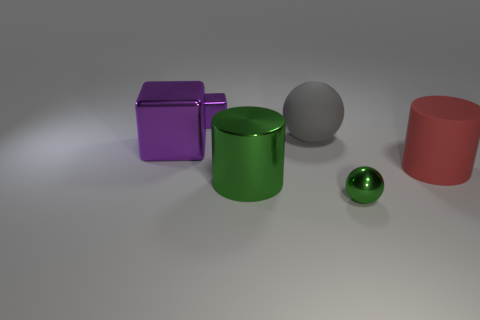In terms of the principle of design, how is balance achieved in this image? Balance is achieved by the strategic placement of the objects, with the larger items on the left seemingly weighing against the smaller ones on the right, and the spherical forms complementing the cuboid shapes. 